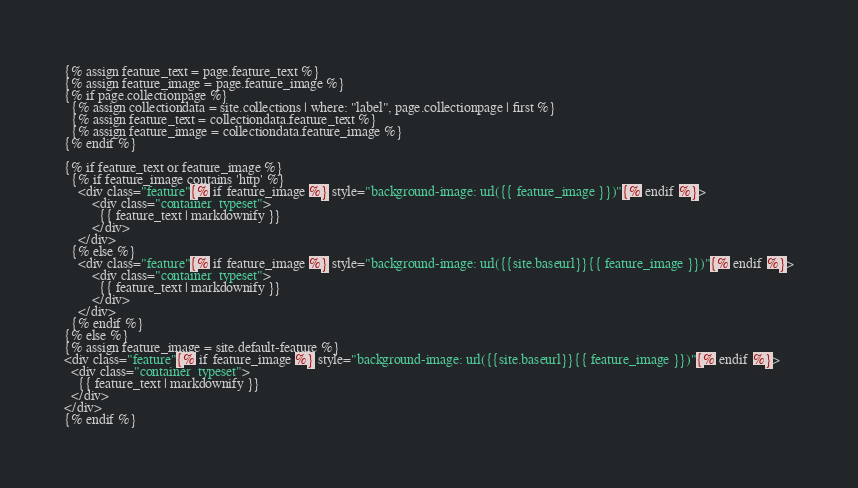Convert code to text. <code><loc_0><loc_0><loc_500><loc_500><_HTML_>{% assign feature_text = page.feature_text %}
{% assign feature_image = page.feature_image %}
{% if page.collectionpage %}
  {% assign collectiondata = site.collections | where: "label", page.collectionpage | first %}
  {% assign feature_text = collectiondata.feature_text %}
  {% assign feature_image = collectiondata.feature_image %}
{% endif %}

{% if feature_text or feature_image %}
  {% if feature_image contains 'http' %}
    <div class="feature"{% if feature_image %} style="background-image: url({{ feature_image }})"{% endif %}>
        <div class="container  typeset">
          {{ feature_text | markdownify }}
        </div>
    </div>
  {% else %}
    <div class="feature"{% if feature_image %} style="background-image: url({{site.baseurl}}{{ feature_image }})"{% endif %}>
        <div class="container  typeset">
          {{ feature_text | markdownify }}
        </div>
    </div>
  {% endif %}
{% else %}
{% assign feature_image = site.default-feature %}
<div class="feature"{% if feature_image %} style="background-image: url({{site.baseurl}}{{ feature_image }})"{% endif %}>
  <div class="container  typeset">
    {{ feature_text | markdownify }}
  </div>
</div>
{% endif %}
</code> 